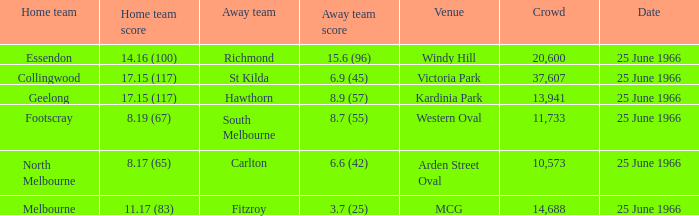Where did the away team score 8.7 (55)? Western Oval. 